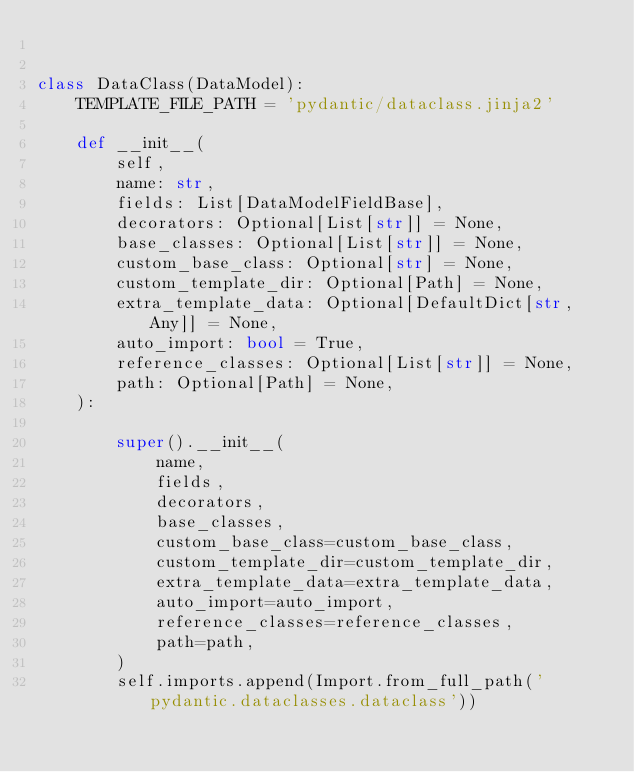<code> <loc_0><loc_0><loc_500><loc_500><_Python_>

class DataClass(DataModel):
    TEMPLATE_FILE_PATH = 'pydantic/dataclass.jinja2'

    def __init__(
        self,
        name: str,
        fields: List[DataModelFieldBase],
        decorators: Optional[List[str]] = None,
        base_classes: Optional[List[str]] = None,
        custom_base_class: Optional[str] = None,
        custom_template_dir: Optional[Path] = None,
        extra_template_data: Optional[DefaultDict[str, Any]] = None,
        auto_import: bool = True,
        reference_classes: Optional[List[str]] = None,
        path: Optional[Path] = None,
    ):

        super().__init__(
            name,
            fields,
            decorators,
            base_classes,
            custom_base_class=custom_base_class,
            custom_template_dir=custom_template_dir,
            extra_template_data=extra_template_data,
            auto_import=auto_import,
            reference_classes=reference_classes,
            path=path,
        )
        self.imports.append(Import.from_full_path('pydantic.dataclasses.dataclass'))
</code> 